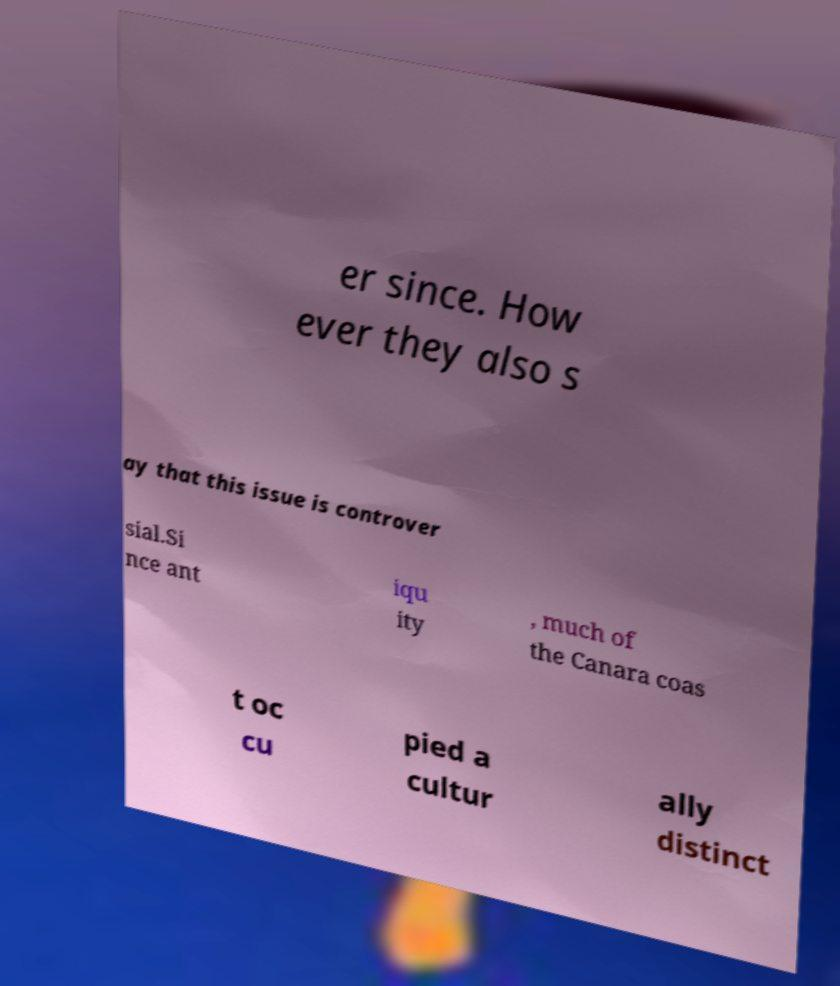Can you accurately transcribe the text from the provided image for me? er since. How ever they also s ay that this issue is controver sial.Si nce ant iqu ity , much of the Canara coas t oc cu pied a cultur ally distinct 